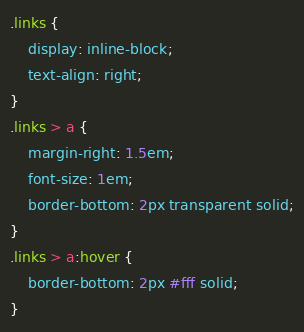<code> <loc_0><loc_0><loc_500><loc_500><_CSS_>.links {
    display: inline-block;
    text-align: right;
}
.links > a {
    margin-right: 1.5em;
    font-size: 1em;
    border-bottom: 2px transparent solid;
}
.links > a:hover {
    border-bottom: 2px #fff solid;
}</code> 